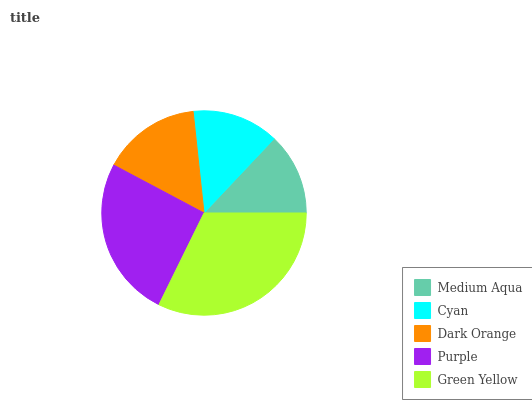Is Medium Aqua the minimum?
Answer yes or no. Yes. Is Green Yellow the maximum?
Answer yes or no. Yes. Is Cyan the minimum?
Answer yes or no. No. Is Cyan the maximum?
Answer yes or no. No. Is Cyan greater than Medium Aqua?
Answer yes or no. Yes. Is Medium Aqua less than Cyan?
Answer yes or no. Yes. Is Medium Aqua greater than Cyan?
Answer yes or no. No. Is Cyan less than Medium Aqua?
Answer yes or no. No. Is Dark Orange the high median?
Answer yes or no. Yes. Is Dark Orange the low median?
Answer yes or no. Yes. Is Green Yellow the high median?
Answer yes or no. No. Is Medium Aqua the low median?
Answer yes or no. No. 